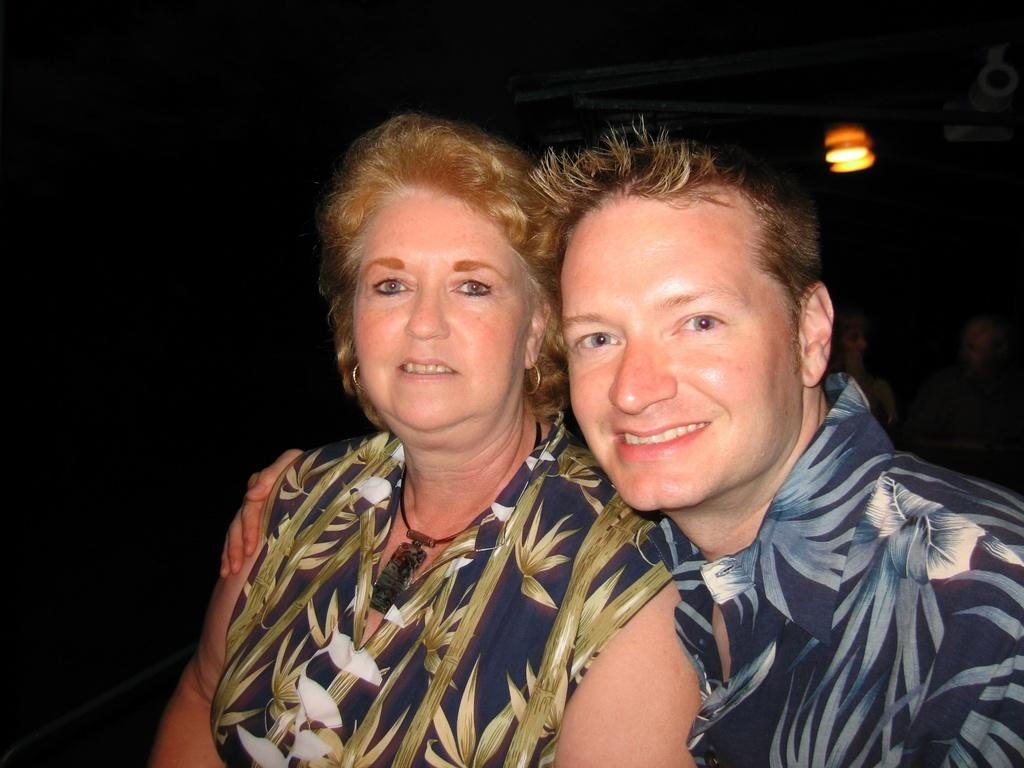How many people are present in the image? There are two persons in the image. What are the two persons wearing? The two persons are wearing dresses. Can you describe the background of the image? There are other persons and lights visible in the background of the image. What is the opinion of the ring on the person's finger in the image? There is no ring present in the image, so it is not possible to determine the opinion of a ring. 